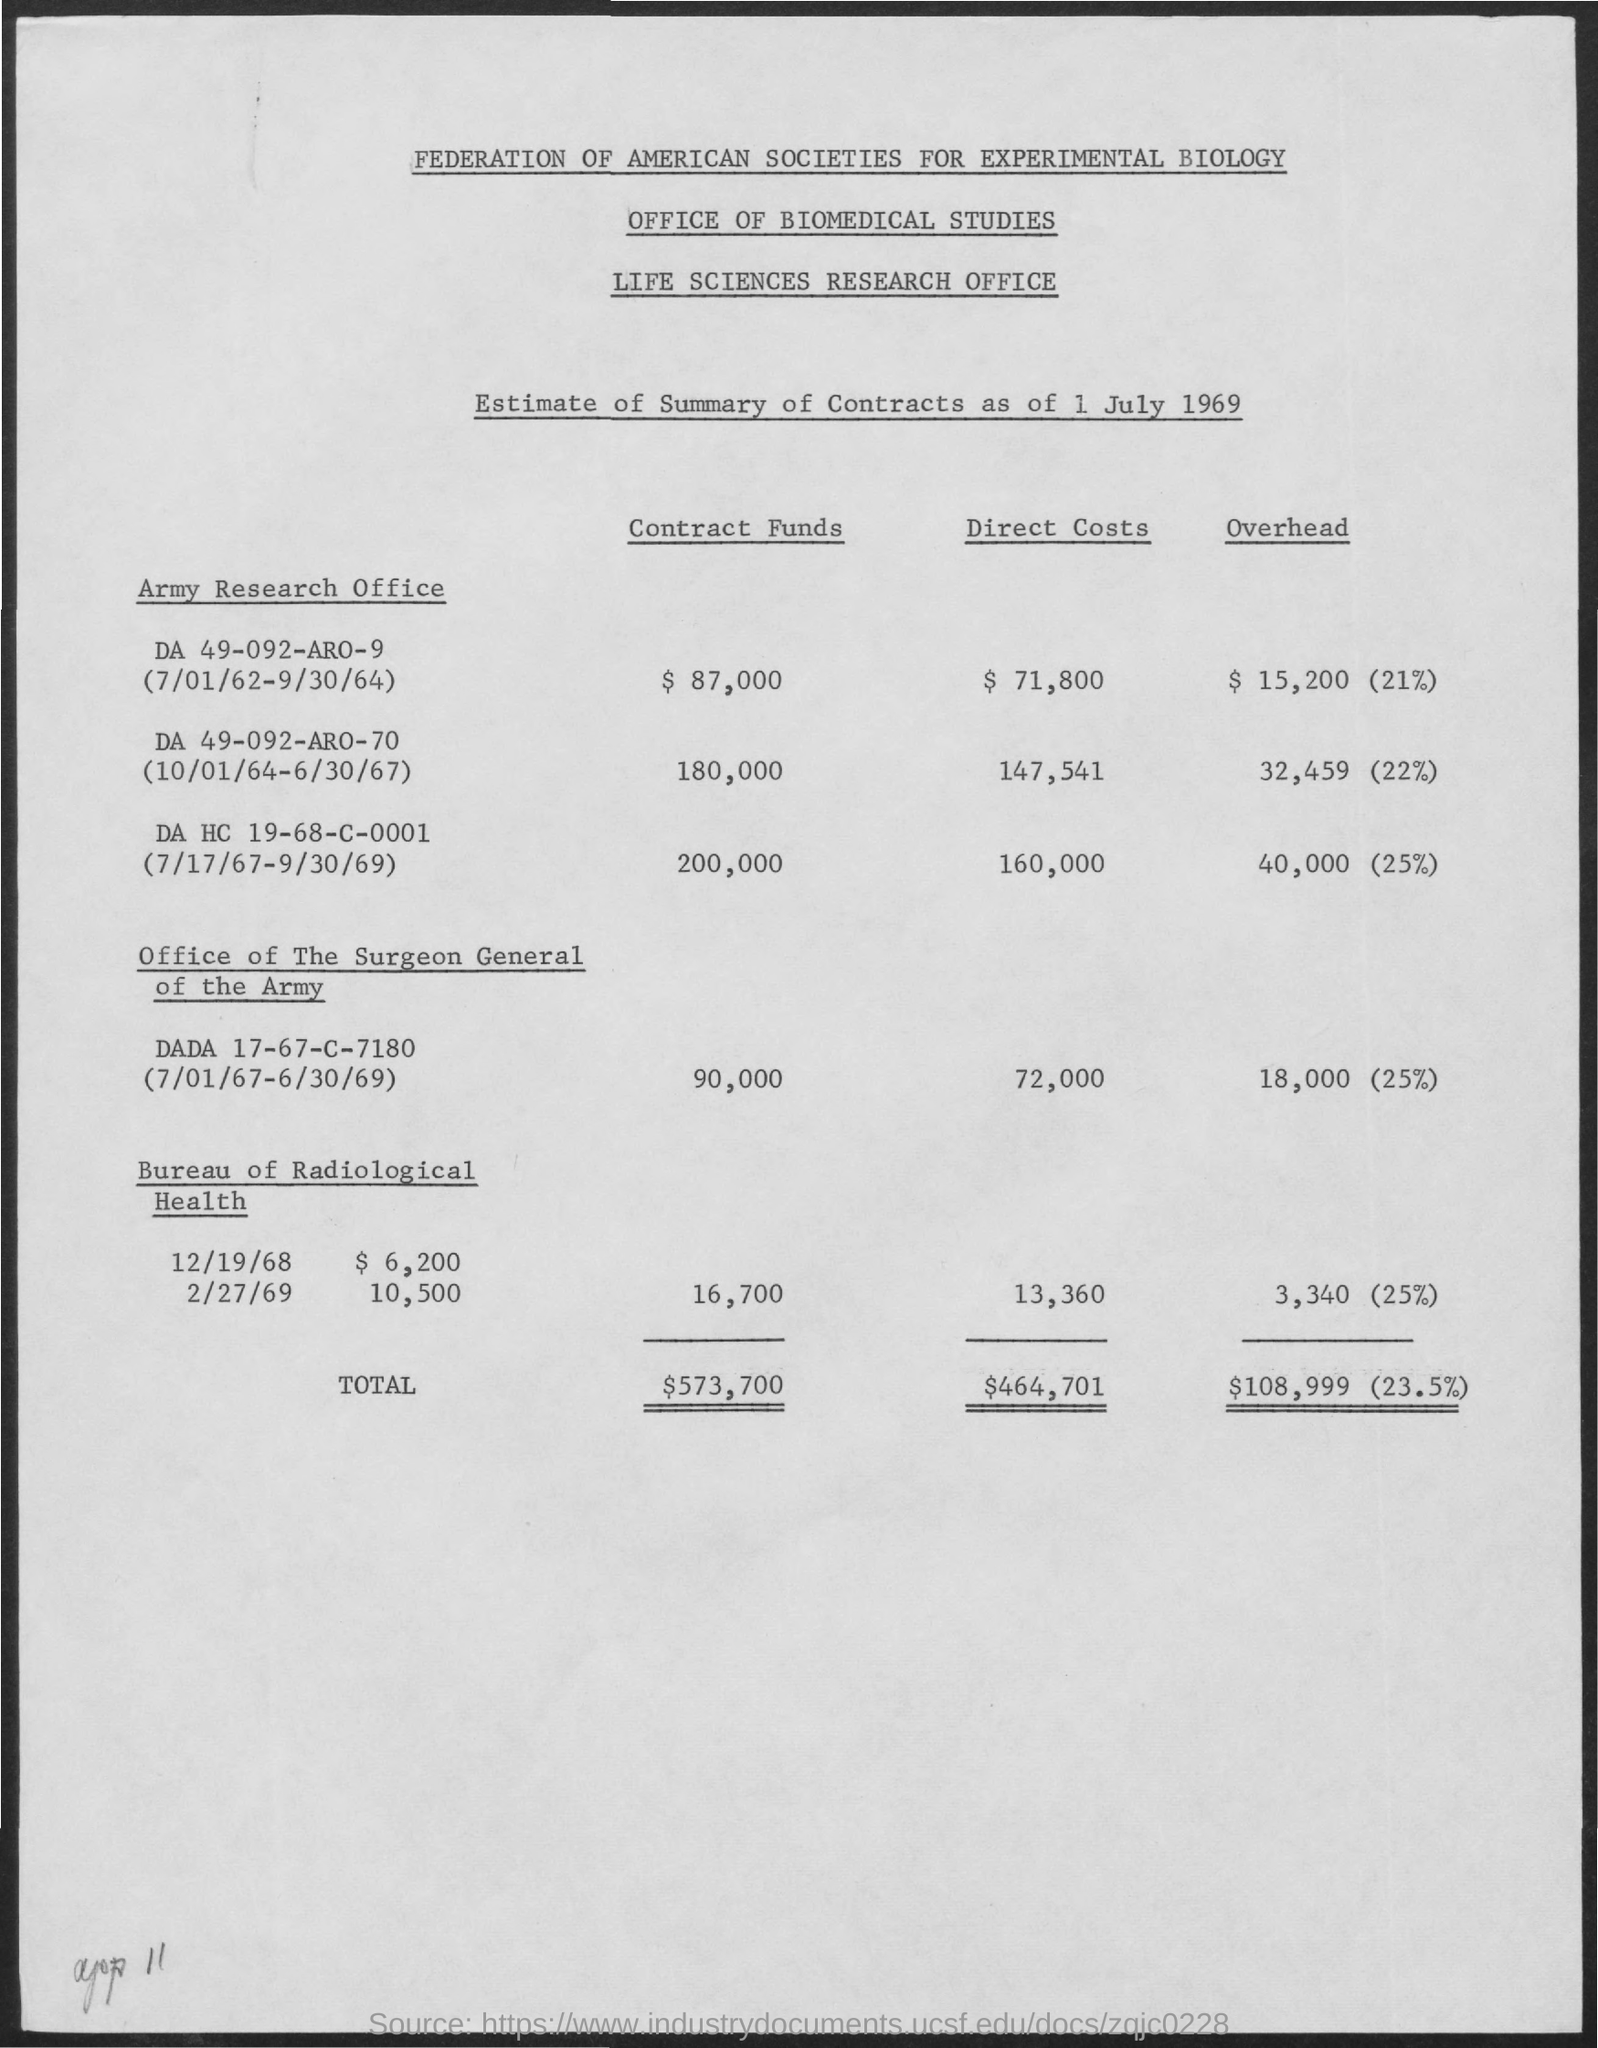Indicate a few pertinent items in this graphic. The document is titled "Federation of American Societies for Experimental Biology. The document contains a second title that reads, "Office of Biomedical Studies. The total direct costs are $464,701. The third title in the document is 'Life Sciences Research Office.' 